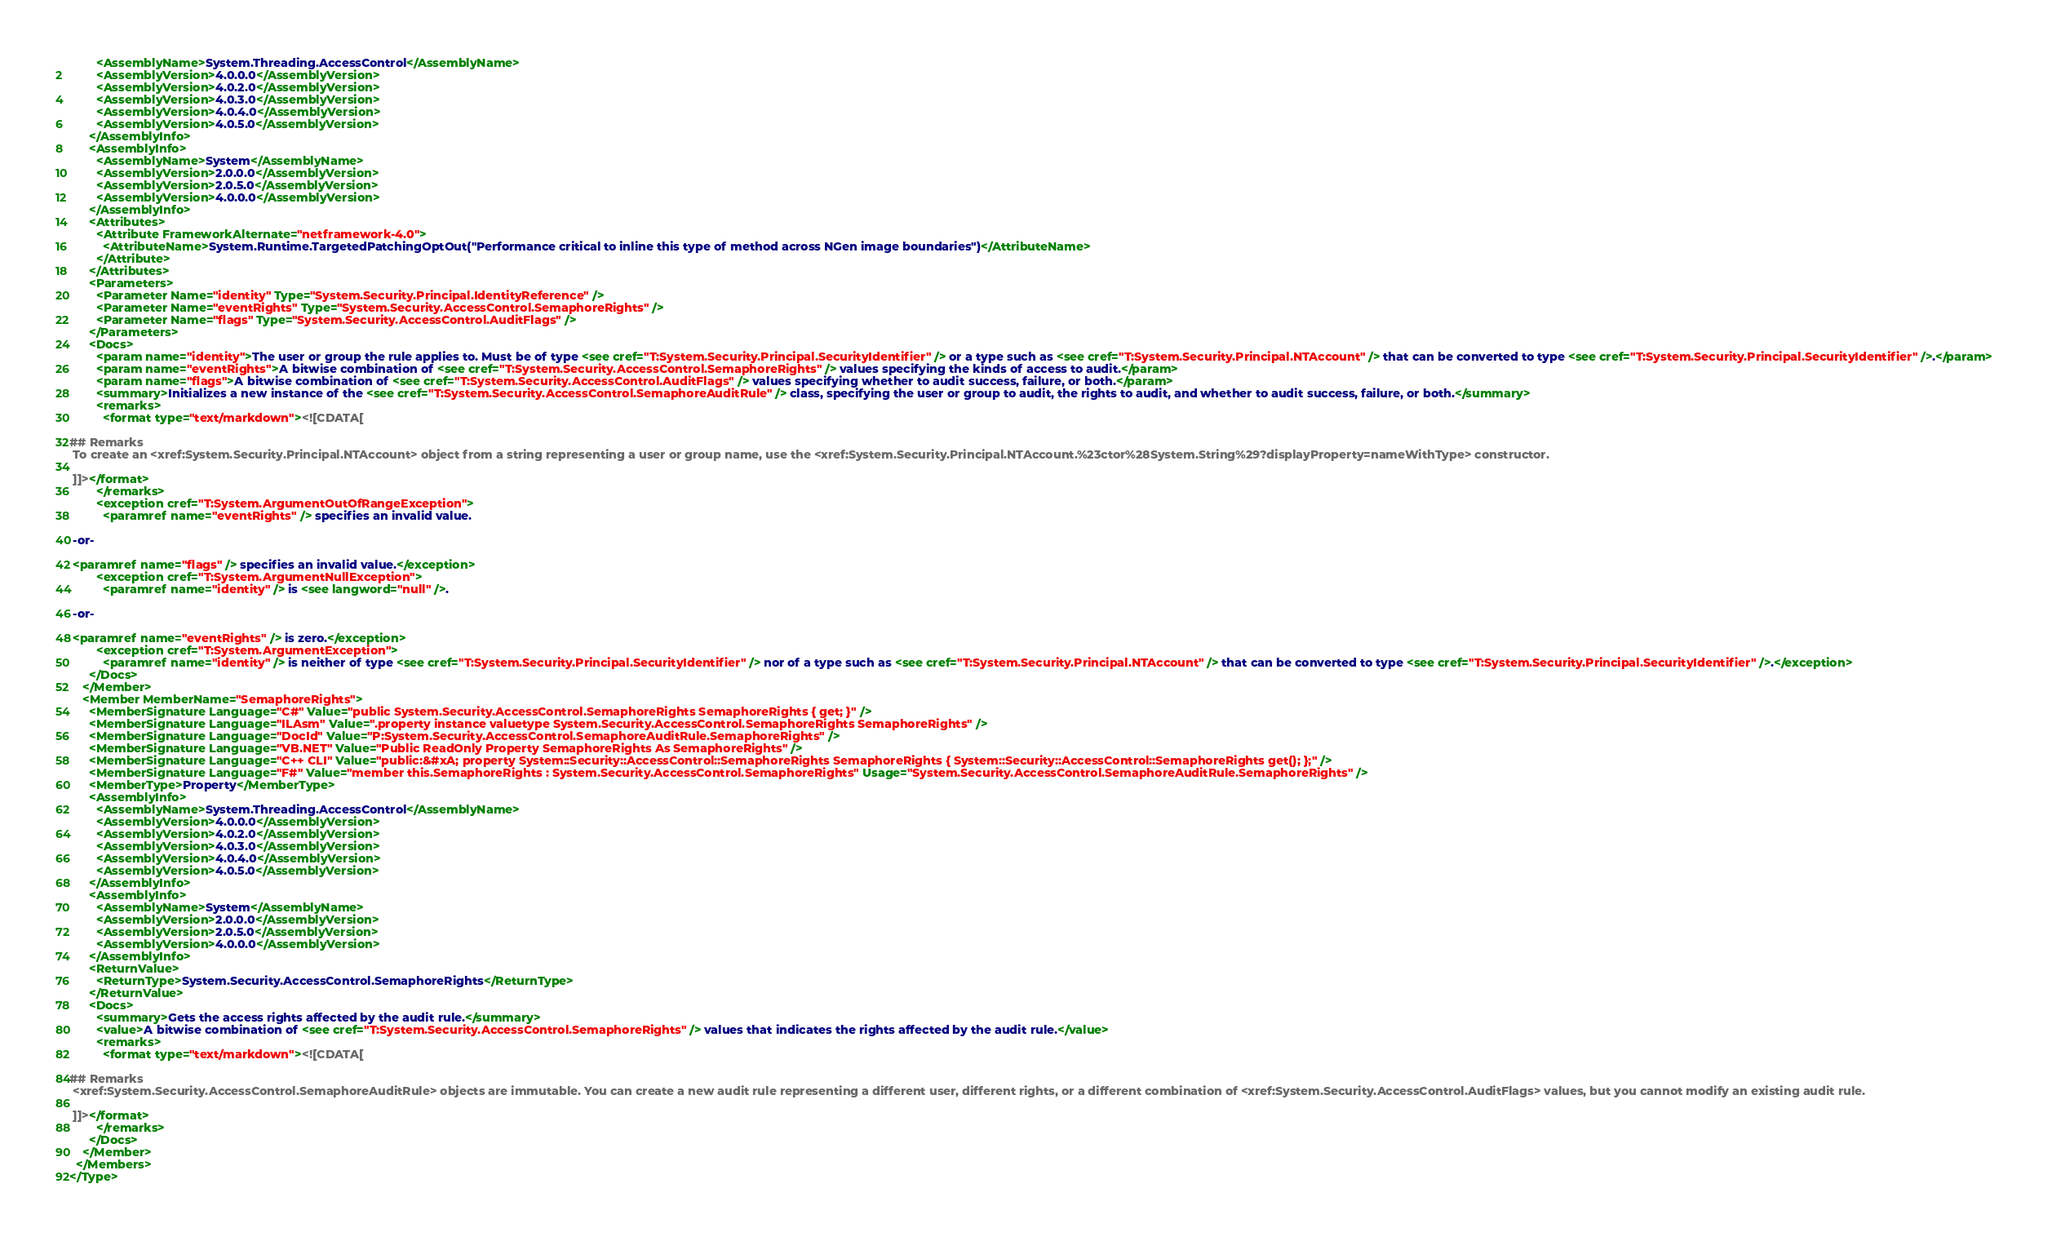Convert code to text. <code><loc_0><loc_0><loc_500><loc_500><_XML_>        <AssemblyName>System.Threading.AccessControl</AssemblyName>
        <AssemblyVersion>4.0.0.0</AssemblyVersion>
        <AssemblyVersion>4.0.2.0</AssemblyVersion>
        <AssemblyVersion>4.0.3.0</AssemblyVersion>
        <AssemblyVersion>4.0.4.0</AssemblyVersion>
        <AssemblyVersion>4.0.5.0</AssemblyVersion>
      </AssemblyInfo>
      <AssemblyInfo>
        <AssemblyName>System</AssemblyName>
        <AssemblyVersion>2.0.0.0</AssemblyVersion>
        <AssemblyVersion>2.0.5.0</AssemblyVersion>
        <AssemblyVersion>4.0.0.0</AssemblyVersion>
      </AssemblyInfo>
      <Attributes>
        <Attribute FrameworkAlternate="netframework-4.0">
          <AttributeName>System.Runtime.TargetedPatchingOptOut("Performance critical to inline this type of method across NGen image boundaries")</AttributeName>
        </Attribute>
      </Attributes>
      <Parameters>
        <Parameter Name="identity" Type="System.Security.Principal.IdentityReference" />
        <Parameter Name="eventRights" Type="System.Security.AccessControl.SemaphoreRights" />
        <Parameter Name="flags" Type="System.Security.AccessControl.AuditFlags" />
      </Parameters>
      <Docs>
        <param name="identity">The user or group the rule applies to. Must be of type <see cref="T:System.Security.Principal.SecurityIdentifier" /> or a type such as <see cref="T:System.Security.Principal.NTAccount" /> that can be converted to type <see cref="T:System.Security.Principal.SecurityIdentifier" />.</param>
        <param name="eventRights">A bitwise combination of <see cref="T:System.Security.AccessControl.SemaphoreRights" /> values specifying the kinds of access to audit.</param>
        <param name="flags">A bitwise combination of <see cref="T:System.Security.AccessControl.AuditFlags" /> values specifying whether to audit success, failure, or both.</param>
        <summary>Initializes a new instance of the <see cref="T:System.Security.AccessControl.SemaphoreAuditRule" /> class, specifying the user or group to audit, the rights to audit, and whether to audit success, failure, or both.</summary>
        <remarks>
          <format type="text/markdown"><![CDATA[  
  
## Remarks  
 To create an <xref:System.Security.Principal.NTAccount> object from a string representing a user or group name, use the <xref:System.Security.Principal.NTAccount.%23ctor%28System.String%29?displayProperty=nameWithType> constructor.  
  
 ]]></format>
        </remarks>
        <exception cref="T:System.ArgumentOutOfRangeException">
          <paramref name="eventRights" /> specifies an invalid value.  
  
 -or-  
  
 <paramref name="flags" /> specifies an invalid value.</exception>
        <exception cref="T:System.ArgumentNullException">
          <paramref name="identity" /> is <see langword="null" />.  
  
 -or-  
  
 <paramref name="eventRights" /> is zero.</exception>
        <exception cref="T:System.ArgumentException">
          <paramref name="identity" /> is neither of type <see cref="T:System.Security.Principal.SecurityIdentifier" /> nor of a type such as <see cref="T:System.Security.Principal.NTAccount" /> that can be converted to type <see cref="T:System.Security.Principal.SecurityIdentifier" />.</exception>
      </Docs>
    </Member>
    <Member MemberName="SemaphoreRights">
      <MemberSignature Language="C#" Value="public System.Security.AccessControl.SemaphoreRights SemaphoreRights { get; }" />
      <MemberSignature Language="ILAsm" Value=".property instance valuetype System.Security.AccessControl.SemaphoreRights SemaphoreRights" />
      <MemberSignature Language="DocId" Value="P:System.Security.AccessControl.SemaphoreAuditRule.SemaphoreRights" />
      <MemberSignature Language="VB.NET" Value="Public ReadOnly Property SemaphoreRights As SemaphoreRights" />
      <MemberSignature Language="C++ CLI" Value="public:&#xA; property System::Security::AccessControl::SemaphoreRights SemaphoreRights { System::Security::AccessControl::SemaphoreRights get(); };" />
      <MemberSignature Language="F#" Value="member this.SemaphoreRights : System.Security.AccessControl.SemaphoreRights" Usage="System.Security.AccessControl.SemaphoreAuditRule.SemaphoreRights" />
      <MemberType>Property</MemberType>
      <AssemblyInfo>
        <AssemblyName>System.Threading.AccessControl</AssemblyName>
        <AssemblyVersion>4.0.0.0</AssemblyVersion>
        <AssemblyVersion>4.0.2.0</AssemblyVersion>
        <AssemblyVersion>4.0.3.0</AssemblyVersion>
        <AssemblyVersion>4.0.4.0</AssemblyVersion>
        <AssemblyVersion>4.0.5.0</AssemblyVersion>
      </AssemblyInfo>
      <AssemblyInfo>
        <AssemblyName>System</AssemblyName>
        <AssemblyVersion>2.0.0.0</AssemblyVersion>
        <AssemblyVersion>2.0.5.0</AssemblyVersion>
        <AssemblyVersion>4.0.0.0</AssemblyVersion>
      </AssemblyInfo>
      <ReturnValue>
        <ReturnType>System.Security.AccessControl.SemaphoreRights</ReturnType>
      </ReturnValue>
      <Docs>
        <summary>Gets the access rights affected by the audit rule.</summary>
        <value>A bitwise combination of <see cref="T:System.Security.AccessControl.SemaphoreRights" /> values that indicates the rights affected by the audit rule.</value>
        <remarks>
          <format type="text/markdown"><![CDATA[  
  
## Remarks  
 <xref:System.Security.AccessControl.SemaphoreAuditRule> objects are immutable. You can create a new audit rule representing a different user, different rights, or a different combination of <xref:System.Security.AccessControl.AuditFlags> values, but you cannot modify an existing audit rule.  
  
 ]]></format>
        </remarks>
      </Docs>
    </Member>
  </Members>
</Type>
</code> 